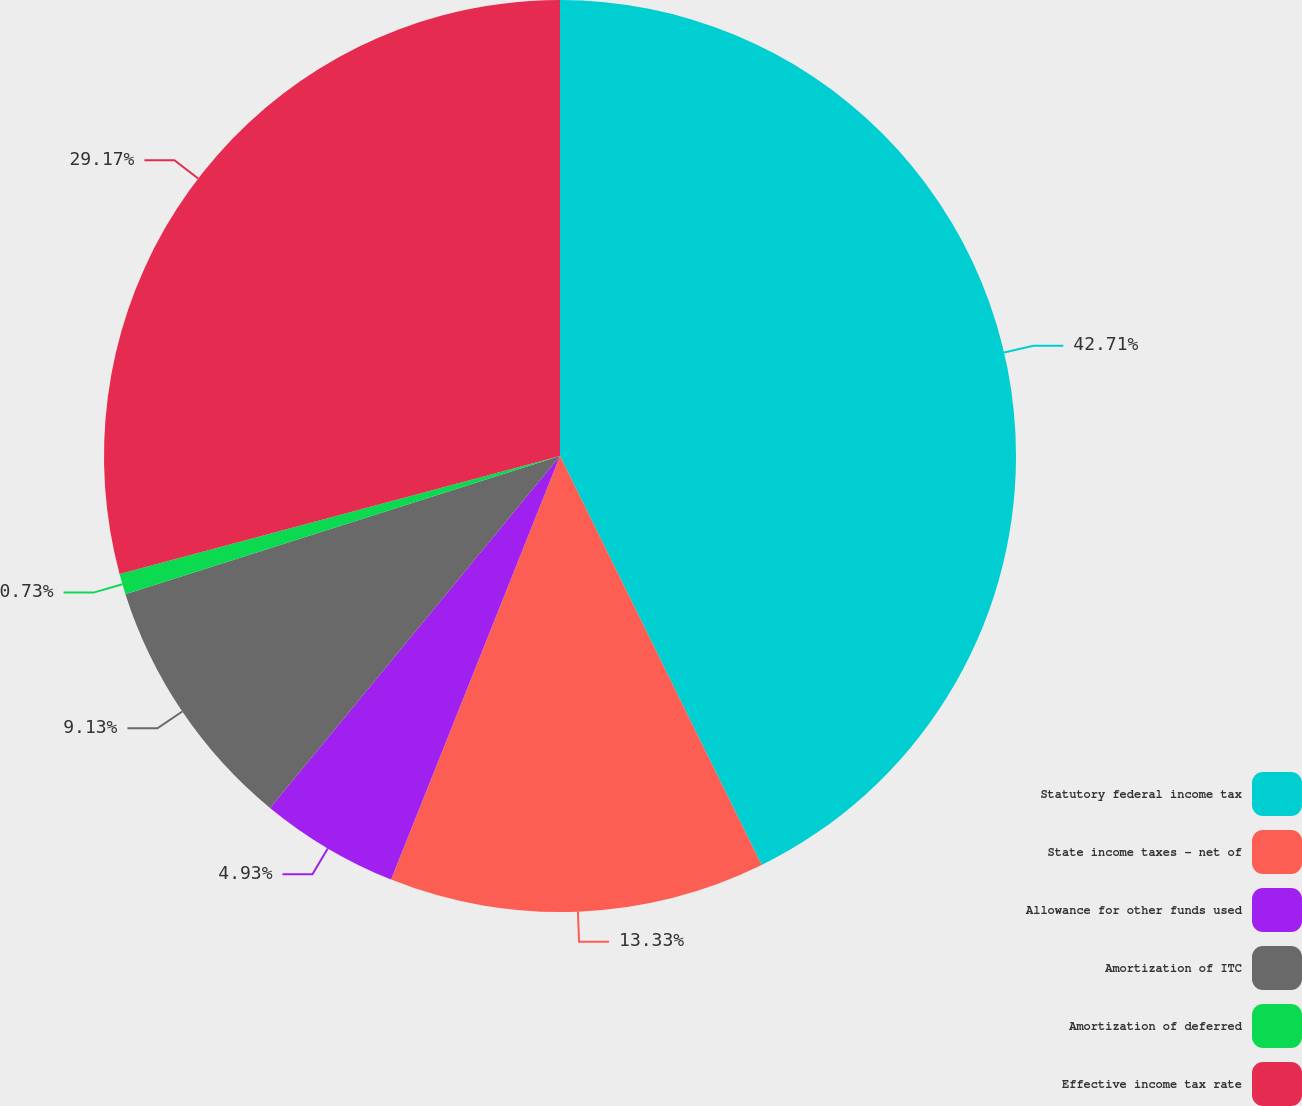<chart> <loc_0><loc_0><loc_500><loc_500><pie_chart><fcel>Statutory federal income tax<fcel>State income taxes - net of<fcel>Allowance for other funds used<fcel>Amortization of ITC<fcel>Amortization of deferred<fcel>Effective income tax rate<nl><fcel>42.71%<fcel>13.33%<fcel>4.93%<fcel>9.13%<fcel>0.73%<fcel>29.17%<nl></chart> 